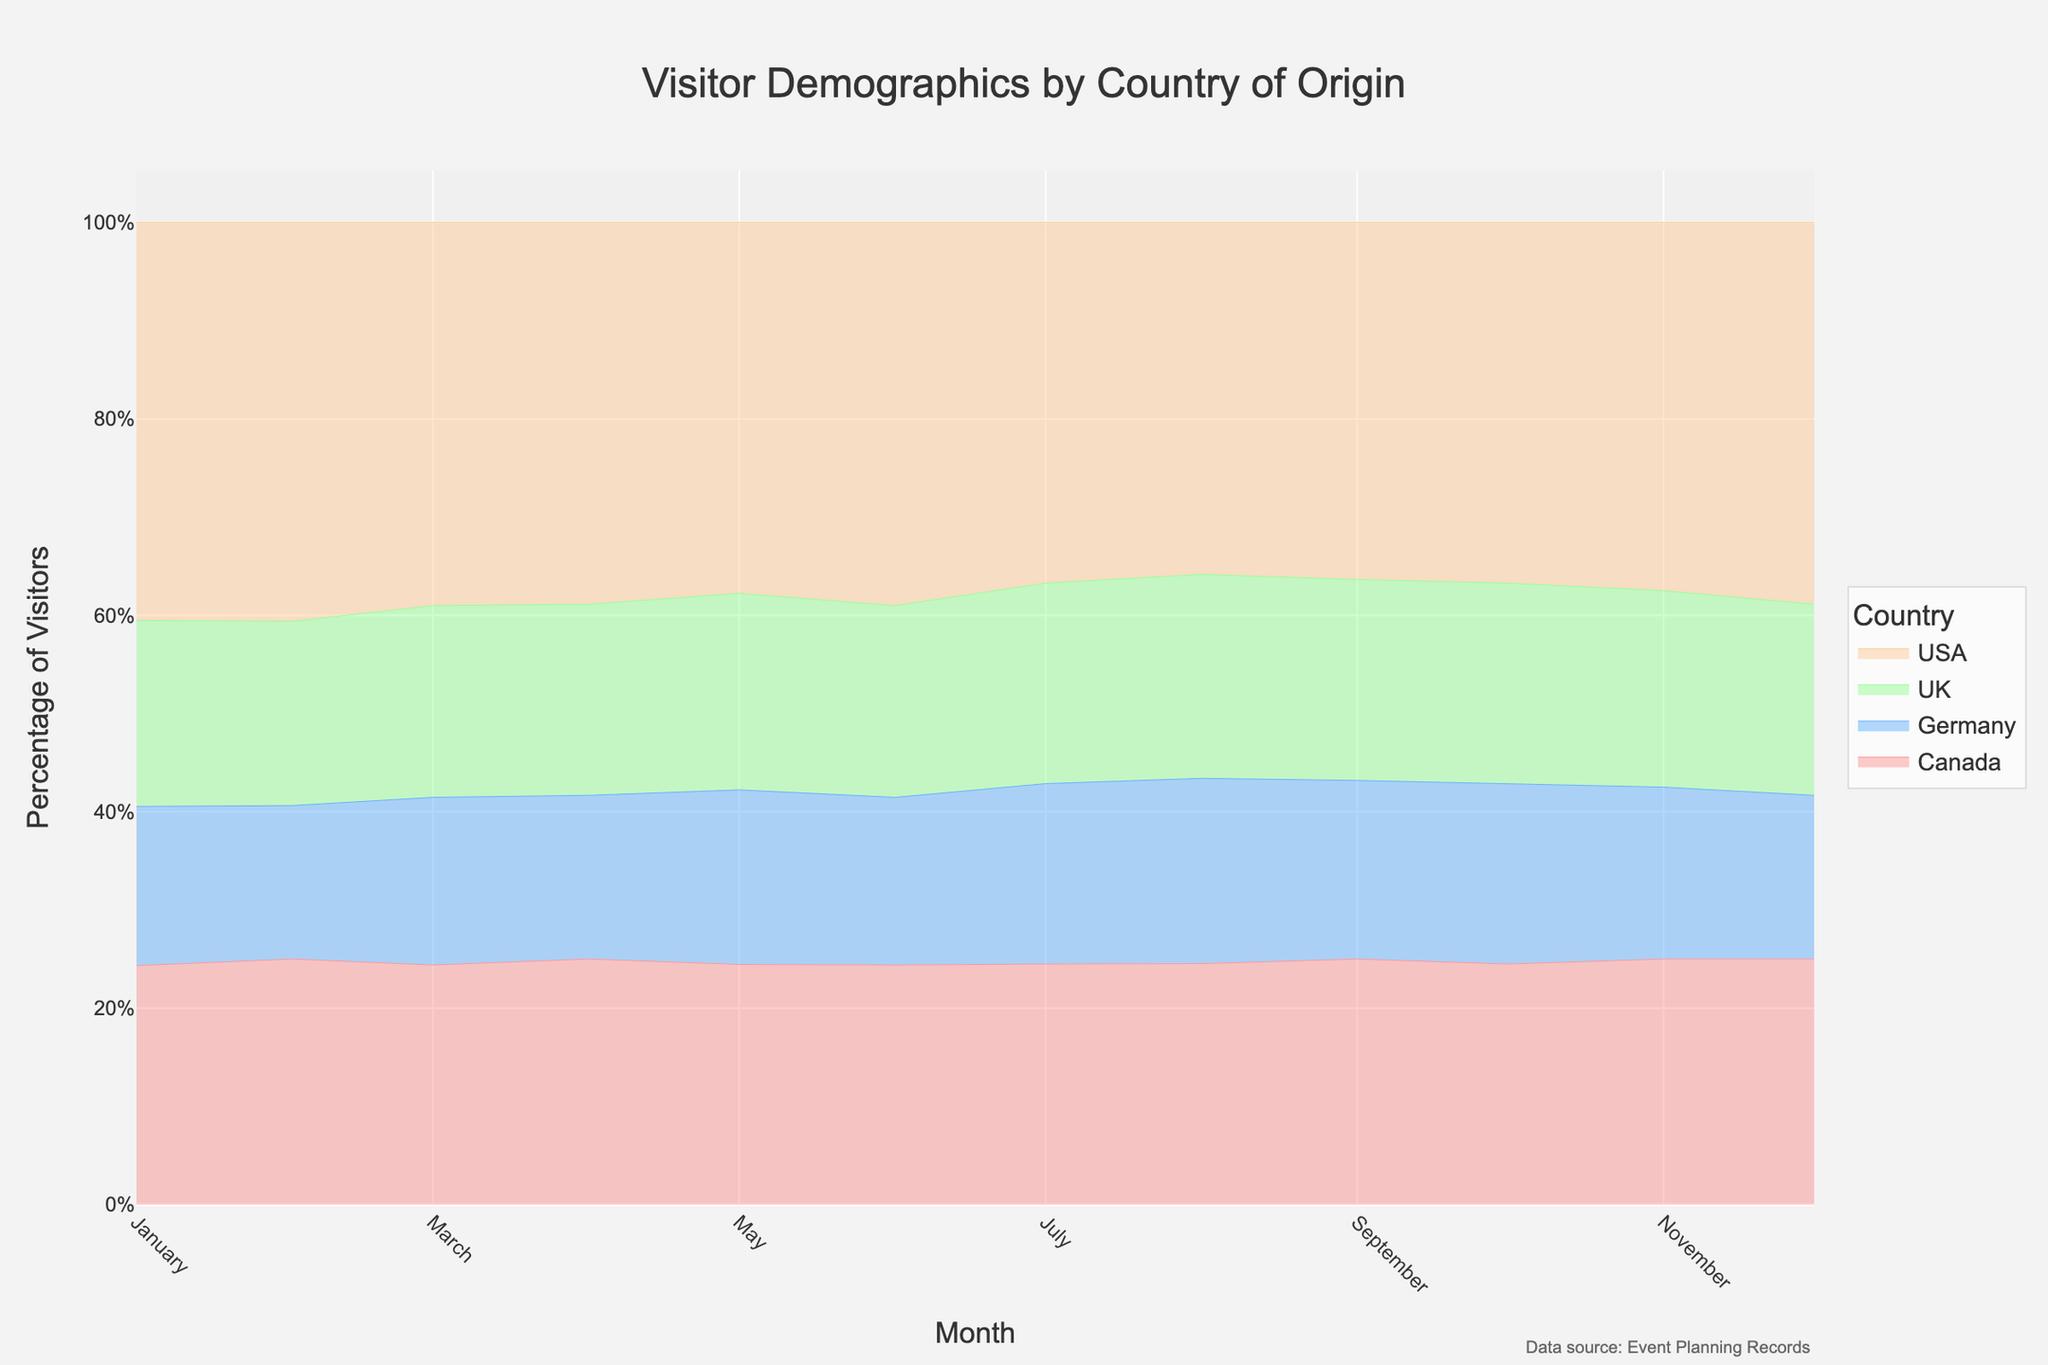What is the title of the figure? The title is located at the top of the figure and is usually the largest text. It reads, "Visitor Demographics by Country of Origin."
Answer: Visitor Demographics by Country of Origin Which month had the peak percentage of visitors from Canada? To find the peak percentage, look at the month where Canada's area in the stackgroup is the largest visually. This appears to be in August.
Answer: August How many countries' visitor data are represented in the figure? Different countries are represented by different stacked areas in the chart. A quick count of the legend entries or unique colors would show there are four countries: USA, Canada, UK, and Germany.
Answer: 4 When there is the least percentage of visitors from the UK? The figure shows the percentage of visitors from different countries over time. The least percentage from the UK occurs where the UK's stack is the smallest, which is in February.
Answer: February Which month shows the highest percentage of visitors from the USA? Look at the stacked area for the USA and find the month where its stack is the largest. The highest percentage from the USA appears to be in August.
Answer: August Compare the percentage of visitors from the UK and Germany in June. Which one is higher? Stay focused on June's line and compare the sections representing the UK and Germany. The UK has a larger area than Germany in June.
Answer: The UK What is the trend for visitor percentages from Germany throughout the year? Look for the area of Germany within the stacked regions. Germany's percentage starts higher in January, then decreases, gradually rising again until August, and falls towards December.
Answer: Decreasing, then rising, then decreasing If the total number of visitors in each month is consistent, which country seems to have the most stable visitor percentage throughout the year? Look for the country whose area shows the least fluctuation over the months. Canada's curve appears to be the most stable across months.
Answer: Canada Which month had the smallest total number of visitors? While the figure represents percentages, the month with the smallest total visitors will have the smallest total stack height. The smallest total height is in February.
Answer: February 